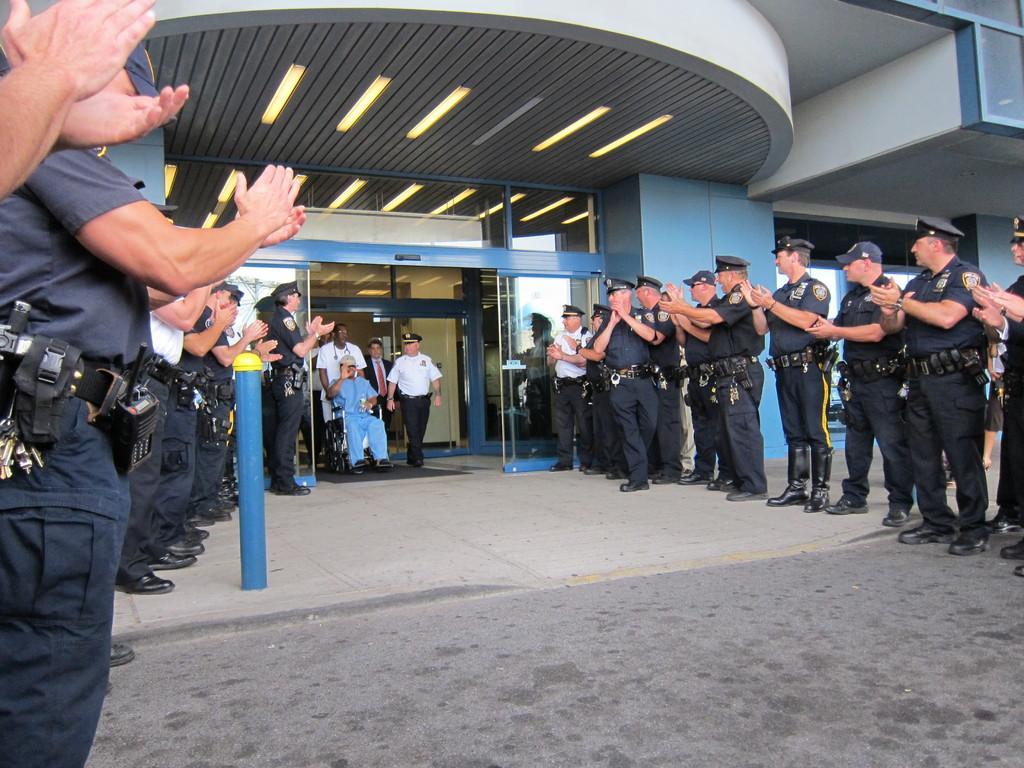Please provide a concise description of this image. On the left side, there are persons in uniforms, standing and clapping. Beside them, there is a blue color pole on a footpath. In the middle of this image, there is a person in a blue color dress, sitting on a wheelchair, showing a hand, holding a bottle with a hand. Back to him, there is a person in white color dress, holding that wheel chair. Beside him, there are other persons walking. On the right side, there are persons in uniforms, standing and clapping. Above them, there are lights attached to the roof of a building which is having glass doors and windows. 